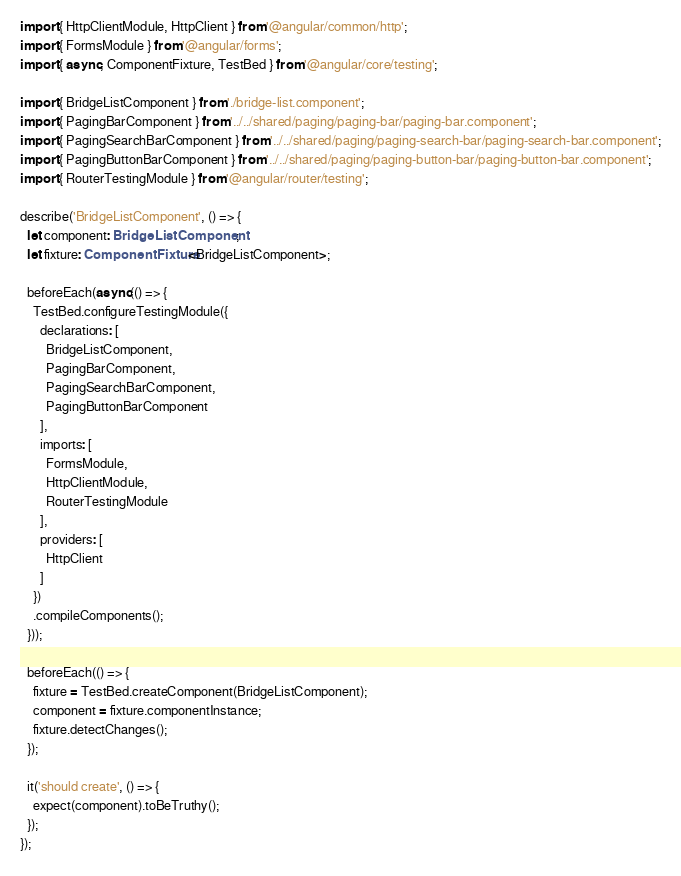Convert code to text. <code><loc_0><loc_0><loc_500><loc_500><_TypeScript_>import { HttpClientModule, HttpClient } from '@angular/common/http';
import { FormsModule } from '@angular/forms';
import { async, ComponentFixture, TestBed } from '@angular/core/testing';

import { BridgeListComponent } from './bridge-list.component';
import { PagingBarComponent } from '../../shared/paging/paging-bar/paging-bar.component';
import { PagingSearchBarComponent } from '../../shared/paging/paging-search-bar/paging-search-bar.component';
import { PagingButtonBarComponent } from '../../shared/paging/paging-button-bar/paging-button-bar.component';
import { RouterTestingModule } from '@angular/router/testing';

describe('BridgeListComponent', () => {
  let component: BridgeListComponent;
  let fixture: ComponentFixture<BridgeListComponent>;

  beforeEach(async(() => {
    TestBed.configureTestingModule({
      declarations: [
        BridgeListComponent,
        PagingBarComponent,
        PagingSearchBarComponent,
        PagingButtonBarComponent
      ],
      imports: [
        FormsModule,
        HttpClientModule,
        RouterTestingModule
      ],
      providers: [
        HttpClient
      ]
    })
    .compileComponents();
  }));

  beforeEach(() => {
    fixture = TestBed.createComponent(BridgeListComponent);
    component = fixture.componentInstance;
    fixture.detectChanges();
  });

  it('should create', () => {
    expect(component).toBeTruthy();
  });
});
</code> 